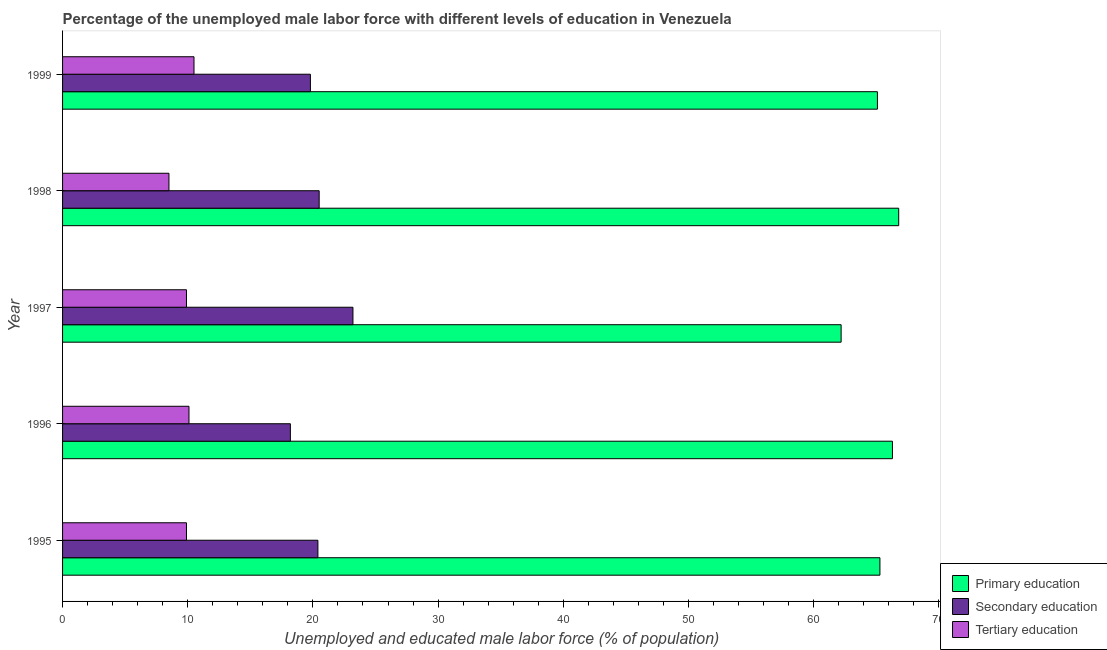How many different coloured bars are there?
Make the answer very short. 3. Are the number of bars per tick equal to the number of legend labels?
Give a very brief answer. Yes. How many bars are there on the 1st tick from the top?
Your answer should be very brief. 3. How many bars are there on the 4th tick from the bottom?
Keep it short and to the point. 3. What is the label of the 1st group of bars from the top?
Your response must be concise. 1999. What is the percentage of male labor force who received tertiary education in 1995?
Give a very brief answer. 9.9. Across all years, what is the maximum percentage of male labor force who received tertiary education?
Give a very brief answer. 10.5. Across all years, what is the minimum percentage of male labor force who received tertiary education?
Make the answer very short. 8.5. In which year was the percentage of male labor force who received tertiary education maximum?
Make the answer very short. 1999. In which year was the percentage of male labor force who received secondary education minimum?
Give a very brief answer. 1996. What is the total percentage of male labor force who received secondary education in the graph?
Provide a short and direct response. 102.1. What is the difference between the percentage of male labor force who received tertiary education in 1997 and the percentage of male labor force who received primary education in 1999?
Offer a terse response. -55.2. What is the average percentage of male labor force who received primary education per year?
Ensure brevity in your answer.  65.14. In the year 1996, what is the difference between the percentage of male labor force who received secondary education and percentage of male labor force who received primary education?
Ensure brevity in your answer.  -48.1. What is the ratio of the percentage of male labor force who received secondary education in 1996 to that in 1999?
Your answer should be very brief. 0.92. What is the difference between the highest and the second highest percentage of male labor force who received primary education?
Provide a short and direct response. 0.5. In how many years, is the percentage of male labor force who received secondary education greater than the average percentage of male labor force who received secondary education taken over all years?
Your answer should be compact. 2. Is the sum of the percentage of male labor force who received primary education in 1995 and 1999 greater than the maximum percentage of male labor force who received tertiary education across all years?
Keep it short and to the point. Yes. What does the 2nd bar from the top in 1995 represents?
Your answer should be compact. Secondary education. What does the 1st bar from the bottom in 1996 represents?
Provide a succinct answer. Primary education. What is the difference between two consecutive major ticks on the X-axis?
Keep it short and to the point. 10. Does the graph contain grids?
Keep it short and to the point. No. Where does the legend appear in the graph?
Provide a succinct answer. Bottom right. How many legend labels are there?
Offer a terse response. 3. How are the legend labels stacked?
Offer a terse response. Vertical. What is the title of the graph?
Provide a succinct answer. Percentage of the unemployed male labor force with different levels of education in Venezuela. Does "Poland" appear as one of the legend labels in the graph?
Your response must be concise. No. What is the label or title of the X-axis?
Provide a succinct answer. Unemployed and educated male labor force (% of population). What is the label or title of the Y-axis?
Offer a very short reply. Year. What is the Unemployed and educated male labor force (% of population) of Primary education in 1995?
Offer a very short reply. 65.3. What is the Unemployed and educated male labor force (% of population) in Secondary education in 1995?
Ensure brevity in your answer.  20.4. What is the Unemployed and educated male labor force (% of population) of Tertiary education in 1995?
Offer a terse response. 9.9. What is the Unemployed and educated male labor force (% of population) in Primary education in 1996?
Make the answer very short. 66.3. What is the Unemployed and educated male labor force (% of population) of Secondary education in 1996?
Provide a succinct answer. 18.2. What is the Unemployed and educated male labor force (% of population) of Tertiary education in 1996?
Your response must be concise. 10.1. What is the Unemployed and educated male labor force (% of population) of Primary education in 1997?
Provide a short and direct response. 62.2. What is the Unemployed and educated male labor force (% of population) of Secondary education in 1997?
Your answer should be compact. 23.2. What is the Unemployed and educated male labor force (% of population) of Tertiary education in 1997?
Give a very brief answer. 9.9. What is the Unemployed and educated male labor force (% of population) of Primary education in 1998?
Keep it short and to the point. 66.8. What is the Unemployed and educated male labor force (% of population) in Primary education in 1999?
Give a very brief answer. 65.1. What is the Unemployed and educated male labor force (% of population) in Secondary education in 1999?
Give a very brief answer. 19.8. What is the Unemployed and educated male labor force (% of population) in Tertiary education in 1999?
Offer a terse response. 10.5. Across all years, what is the maximum Unemployed and educated male labor force (% of population) in Primary education?
Your answer should be compact. 66.8. Across all years, what is the maximum Unemployed and educated male labor force (% of population) of Secondary education?
Your answer should be very brief. 23.2. Across all years, what is the minimum Unemployed and educated male labor force (% of population) of Primary education?
Provide a succinct answer. 62.2. Across all years, what is the minimum Unemployed and educated male labor force (% of population) in Secondary education?
Your answer should be compact. 18.2. Across all years, what is the minimum Unemployed and educated male labor force (% of population) in Tertiary education?
Provide a succinct answer. 8.5. What is the total Unemployed and educated male labor force (% of population) in Primary education in the graph?
Ensure brevity in your answer.  325.7. What is the total Unemployed and educated male labor force (% of population) of Secondary education in the graph?
Your answer should be very brief. 102.1. What is the total Unemployed and educated male labor force (% of population) in Tertiary education in the graph?
Ensure brevity in your answer.  48.9. What is the difference between the Unemployed and educated male labor force (% of population) in Primary education in 1995 and that in 1996?
Offer a terse response. -1. What is the difference between the Unemployed and educated male labor force (% of population) in Secondary education in 1995 and that in 1997?
Offer a very short reply. -2.8. What is the difference between the Unemployed and educated male labor force (% of population) of Tertiary education in 1995 and that in 1997?
Make the answer very short. 0. What is the difference between the Unemployed and educated male labor force (% of population) of Primary education in 1995 and that in 1998?
Provide a succinct answer. -1.5. What is the difference between the Unemployed and educated male labor force (% of population) in Tertiary education in 1995 and that in 1998?
Provide a short and direct response. 1.4. What is the difference between the Unemployed and educated male labor force (% of population) in Primary education in 1995 and that in 1999?
Offer a terse response. 0.2. What is the difference between the Unemployed and educated male labor force (% of population) of Secondary education in 1995 and that in 1999?
Your answer should be compact. 0.6. What is the difference between the Unemployed and educated male labor force (% of population) in Tertiary education in 1995 and that in 1999?
Provide a short and direct response. -0.6. What is the difference between the Unemployed and educated male labor force (% of population) in Primary education in 1996 and that in 1997?
Make the answer very short. 4.1. What is the difference between the Unemployed and educated male labor force (% of population) in Primary education in 1996 and that in 1998?
Offer a very short reply. -0.5. What is the difference between the Unemployed and educated male labor force (% of population) in Secondary education in 1996 and that in 1998?
Give a very brief answer. -2.3. What is the difference between the Unemployed and educated male labor force (% of population) in Tertiary education in 1996 and that in 1998?
Your answer should be very brief. 1.6. What is the difference between the Unemployed and educated male labor force (% of population) in Primary education in 1996 and that in 1999?
Ensure brevity in your answer.  1.2. What is the difference between the Unemployed and educated male labor force (% of population) in Secondary education in 1996 and that in 1999?
Your answer should be compact. -1.6. What is the difference between the Unemployed and educated male labor force (% of population) in Tertiary education in 1996 and that in 1999?
Provide a short and direct response. -0.4. What is the difference between the Unemployed and educated male labor force (% of population) of Primary education in 1997 and that in 1998?
Offer a terse response. -4.6. What is the difference between the Unemployed and educated male labor force (% of population) of Tertiary education in 1997 and that in 1998?
Your answer should be very brief. 1.4. What is the difference between the Unemployed and educated male labor force (% of population) in Secondary education in 1998 and that in 1999?
Your answer should be very brief. 0.7. What is the difference between the Unemployed and educated male labor force (% of population) in Tertiary education in 1998 and that in 1999?
Your response must be concise. -2. What is the difference between the Unemployed and educated male labor force (% of population) of Primary education in 1995 and the Unemployed and educated male labor force (% of population) of Secondary education in 1996?
Provide a succinct answer. 47.1. What is the difference between the Unemployed and educated male labor force (% of population) of Primary education in 1995 and the Unemployed and educated male labor force (% of population) of Tertiary education in 1996?
Offer a terse response. 55.2. What is the difference between the Unemployed and educated male labor force (% of population) of Secondary education in 1995 and the Unemployed and educated male labor force (% of population) of Tertiary education in 1996?
Keep it short and to the point. 10.3. What is the difference between the Unemployed and educated male labor force (% of population) of Primary education in 1995 and the Unemployed and educated male labor force (% of population) of Secondary education in 1997?
Ensure brevity in your answer.  42.1. What is the difference between the Unemployed and educated male labor force (% of population) in Primary education in 1995 and the Unemployed and educated male labor force (% of population) in Tertiary education in 1997?
Give a very brief answer. 55.4. What is the difference between the Unemployed and educated male labor force (% of population) in Secondary education in 1995 and the Unemployed and educated male labor force (% of population) in Tertiary education in 1997?
Offer a terse response. 10.5. What is the difference between the Unemployed and educated male labor force (% of population) in Primary education in 1995 and the Unemployed and educated male labor force (% of population) in Secondary education in 1998?
Offer a very short reply. 44.8. What is the difference between the Unemployed and educated male labor force (% of population) of Primary education in 1995 and the Unemployed and educated male labor force (% of population) of Tertiary education in 1998?
Ensure brevity in your answer.  56.8. What is the difference between the Unemployed and educated male labor force (% of population) in Secondary education in 1995 and the Unemployed and educated male labor force (% of population) in Tertiary education in 1998?
Offer a terse response. 11.9. What is the difference between the Unemployed and educated male labor force (% of population) in Primary education in 1995 and the Unemployed and educated male labor force (% of population) in Secondary education in 1999?
Keep it short and to the point. 45.5. What is the difference between the Unemployed and educated male labor force (% of population) in Primary education in 1995 and the Unemployed and educated male labor force (% of population) in Tertiary education in 1999?
Your answer should be compact. 54.8. What is the difference between the Unemployed and educated male labor force (% of population) in Primary education in 1996 and the Unemployed and educated male labor force (% of population) in Secondary education in 1997?
Give a very brief answer. 43.1. What is the difference between the Unemployed and educated male labor force (% of population) in Primary education in 1996 and the Unemployed and educated male labor force (% of population) in Tertiary education in 1997?
Your answer should be very brief. 56.4. What is the difference between the Unemployed and educated male labor force (% of population) of Secondary education in 1996 and the Unemployed and educated male labor force (% of population) of Tertiary education in 1997?
Keep it short and to the point. 8.3. What is the difference between the Unemployed and educated male labor force (% of population) in Primary education in 1996 and the Unemployed and educated male labor force (% of population) in Secondary education in 1998?
Offer a very short reply. 45.8. What is the difference between the Unemployed and educated male labor force (% of population) in Primary education in 1996 and the Unemployed and educated male labor force (% of population) in Tertiary education in 1998?
Ensure brevity in your answer.  57.8. What is the difference between the Unemployed and educated male labor force (% of population) of Primary education in 1996 and the Unemployed and educated male labor force (% of population) of Secondary education in 1999?
Give a very brief answer. 46.5. What is the difference between the Unemployed and educated male labor force (% of population) of Primary education in 1996 and the Unemployed and educated male labor force (% of population) of Tertiary education in 1999?
Your answer should be very brief. 55.8. What is the difference between the Unemployed and educated male labor force (% of population) of Secondary education in 1996 and the Unemployed and educated male labor force (% of population) of Tertiary education in 1999?
Provide a short and direct response. 7.7. What is the difference between the Unemployed and educated male labor force (% of population) in Primary education in 1997 and the Unemployed and educated male labor force (% of population) in Secondary education in 1998?
Give a very brief answer. 41.7. What is the difference between the Unemployed and educated male labor force (% of population) in Primary education in 1997 and the Unemployed and educated male labor force (% of population) in Tertiary education in 1998?
Give a very brief answer. 53.7. What is the difference between the Unemployed and educated male labor force (% of population) in Primary education in 1997 and the Unemployed and educated male labor force (% of population) in Secondary education in 1999?
Keep it short and to the point. 42.4. What is the difference between the Unemployed and educated male labor force (% of population) in Primary education in 1997 and the Unemployed and educated male labor force (% of population) in Tertiary education in 1999?
Ensure brevity in your answer.  51.7. What is the difference between the Unemployed and educated male labor force (% of population) of Secondary education in 1997 and the Unemployed and educated male labor force (% of population) of Tertiary education in 1999?
Offer a very short reply. 12.7. What is the difference between the Unemployed and educated male labor force (% of population) of Primary education in 1998 and the Unemployed and educated male labor force (% of population) of Secondary education in 1999?
Provide a short and direct response. 47. What is the difference between the Unemployed and educated male labor force (% of population) of Primary education in 1998 and the Unemployed and educated male labor force (% of population) of Tertiary education in 1999?
Offer a very short reply. 56.3. What is the difference between the Unemployed and educated male labor force (% of population) in Secondary education in 1998 and the Unemployed and educated male labor force (% of population) in Tertiary education in 1999?
Your response must be concise. 10. What is the average Unemployed and educated male labor force (% of population) of Primary education per year?
Offer a very short reply. 65.14. What is the average Unemployed and educated male labor force (% of population) of Secondary education per year?
Offer a very short reply. 20.42. What is the average Unemployed and educated male labor force (% of population) of Tertiary education per year?
Ensure brevity in your answer.  9.78. In the year 1995, what is the difference between the Unemployed and educated male labor force (% of population) of Primary education and Unemployed and educated male labor force (% of population) of Secondary education?
Your response must be concise. 44.9. In the year 1995, what is the difference between the Unemployed and educated male labor force (% of population) of Primary education and Unemployed and educated male labor force (% of population) of Tertiary education?
Provide a succinct answer. 55.4. In the year 1995, what is the difference between the Unemployed and educated male labor force (% of population) of Secondary education and Unemployed and educated male labor force (% of population) of Tertiary education?
Keep it short and to the point. 10.5. In the year 1996, what is the difference between the Unemployed and educated male labor force (% of population) of Primary education and Unemployed and educated male labor force (% of population) of Secondary education?
Ensure brevity in your answer.  48.1. In the year 1996, what is the difference between the Unemployed and educated male labor force (% of population) of Primary education and Unemployed and educated male labor force (% of population) of Tertiary education?
Provide a succinct answer. 56.2. In the year 1996, what is the difference between the Unemployed and educated male labor force (% of population) of Secondary education and Unemployed and educated male labor force (% of population) of Tertiary education?
Your answer should be very brief. 8.1. In the year 1997, what is the difference between the Unemployed and educated male labor force (% of population) in Primary education and Unemployed and educated male labor force (% of population) in Tertiary education?
Keep it short and to the point. 52.3. In the year 1997, what is the difference between the Unemployed and educated male labor force (% of population) in Secondary education and Unemployed and educated male labor force (% of population) in Tertiary education?
Provide a short and direct response. 13.3. In the year 1998, what is the difference between the Unemployed and educated male labor force (% of population) of Primary education and Unemployed and educated male labor force (% of population) of Secondary education?
Provide a succinct answer. 46.3. In the year 1998, what is the difference between the Unemployed and educated male labor force (% of population) in Primary education and Unemployed and educated male labor force (% of population) in Tertiary education?
Give a very brief answer. 58.3. In the year 1998, what is the difference between the Unemployed and educated male labor force (% of population) in Secondary education and Unemployed and educated male labor force (% of population) in Tertiary education?
Your answer should be very brief. 12. In the year 1999, what is the difference between the Unemployed and educated male labor force (% of population) in Primary education and Unemployed and educated male labor force (% of population) in Secondary education?
Offer a very short reply. 45.3. In the year 1999, what is the difference between the Unemployed and educated male labor force (% of population) of Primary education and Unemployed and educated male labor force (% of population) of Tertiary education?
Make the answer very short. 54.6. In the year 1999, what is the difference between the Unemployed and educated male labor force (% of population) of Secondary education and Unemployed and educated male labor force (% of population) of Tertiary education?
Your response must be concise. 9.3. What is the ratio of the Unemployed and educated male labor force (% of population) in Primary education in 1995 to that in 1996?
Offer a terse response. 0.98. What is the ratio of the Unemployed and educated male labor force (% of population) of Secondary education in 1995 to that in 1996?
Your answer should be compact. 1.12. What is the ratio of the Unemployed and educated male labor force (% of population) of Tertiary education in 1995 to that in 1996?
Your answer should be compact. 0.98. What is the ratio of the Unemployed and educated male labor force (% of population) of Primary education in 1995 to that in 1997?
Make the answer very short. 1.05. What is the ratio of the Unemployed and educated male labor force (% of population) in Secondary education in 1995 to that in 1997?
Your answer should be very brief. 0.88. What is the ratio of the Unemployed and educated male labor force (% of population) in Primary education in 1995 to that in 1998?
Your answer should be very brief. 0.98. What is the ratio of the Unemployed and educated male labor force (% of population) in Secondary education in 1995 to that in 1998?
Your answer should be very brief. 1. What is the ratio of the Unemployed and educated male labor force (% of population) of Tertiary education in 1995 to that in 1998?
Offer a very short reply. 1.16. What is the ratio of the Unemployed and educated male labor force (% of population) in Primary education in 1995 to that in 1999?
Keep it short and to the point. 1. What is the ratio of the Unemployed and educated male labor force (% of population) of Secondary education in 1995 to that in 1999?
Give a very brief answer. 1.03. What is the ratio of the Unemployed and educated male labor force (% of population) in Tertiary education in 1995 to that in 1999?
Ensure brevity in your answer.  0.94. What is the ratio of the Unemployed and educated male labor force (% of population) in Primary education in 1996 to that in 1997?
Provide a short and direct response. 1.07. What is the ratio of the Unemployed and educated male labor force (% of population) in Secondary education in 1996 to that in 1997?
Ensure brevity in your answer.  0.78. What is the ratio of the Unemployed and educated male labor force (% of population) of Tertiary education in 1996 to that in 1997?
Ensure brevity in your answer.  1.02. What is the ratio of the Unemployed and educated male labor force (% of population) of Primary education in 1996 to that in 1998?
Provide a short and direct response. 0.99. What is the ratio of the Unemployed and educated male labor force (% of population) in Secondary education in 1996 to that in 1998?
Ensure brevity in your answer.  0.89. What is the ratio of the Unemployed and educated male labor force (% of population) in Tertiary education in 1996 to that in 1998?
Keep it short and to the point. 1.19. What is the ratio of the Unemployed and educated male labor force (% of population) of Primary education in 1996 to that in 1999?
Your answer should be compact. 1.02. What is the ratio of the Unemployed and educated male labor force (% of population) of Secondary education in 1996 to that in 1999?
Make the answer very short. 0.92. What is the ratio of the Unemployed and educated male labor force (% of population) in Tertiary education in 1996 to that in 1999?
Your response must be concise. 0.96. What is the ratio of the Unemployed and educated male labor force (% of population) in Primary education in 1997 to that in 1998?
Provide a succinct answer. 0.93. What is the ratio of the Unemployed and educated male labor force (% of population) of Secondary education in 1997 to that in 1998?
Your answer should be very brief. 1.13. What is the ratio of the Unemployed and educated male labor force (% of population) in Tertiary education in 1997 to that in 1998?
Offer a very short reply. 1.16. What is the ratio of the Unemployed and educated male labor force (% of population) in Primary education in 1997 to that in 1999?
Provide a short and direct response. 0.96. What is the ratio of the Unemployed and educated male labor force (% of population) in Secondary education in 1997 to that in 1999?
Offer a very short reply. 1.17. What is the ratio of the Unemployed and educated male labor force (% of population) of Tertiary education in 1997 to that in 1999?
Provide a short and direct response. 0.94. What is the ratio of the Unemployed and educated male labor force (% of population) in Primary education in 1998 to that in 1999?
Ensure brevity in your answer.  1.03. What is the ratio of the Unemployed and educated male labor force (% of population) of Secondary education in 1998 to that in 1999?
Provide a succinct answer. 1.04. What is the ratio of the Unemployed and educated male labor force (% of population) of Tertiary education in 1998 to that in 1999?
Ensure brevity in your answer.  0.81. What is the difference between the highest and the second highest Unemployed and educated male labor force (% of population) in Primary education?
Ensure brevity in your answer.  0.5. What is the difference between the highest and the second highest Unemployed and educated male labor force (% of population) of Secondary education?
Your response must be concise. 2.7. What is the difference between the highest and the second highest Unemployed and educated male labor force (% of population) in Tertiary education?
Make the answer very short. 0.4. What is the difference between the highest and the lowest Unemployed and educated male labor force (% of population) of Primary education?
Make the answer very short. 4.6. 